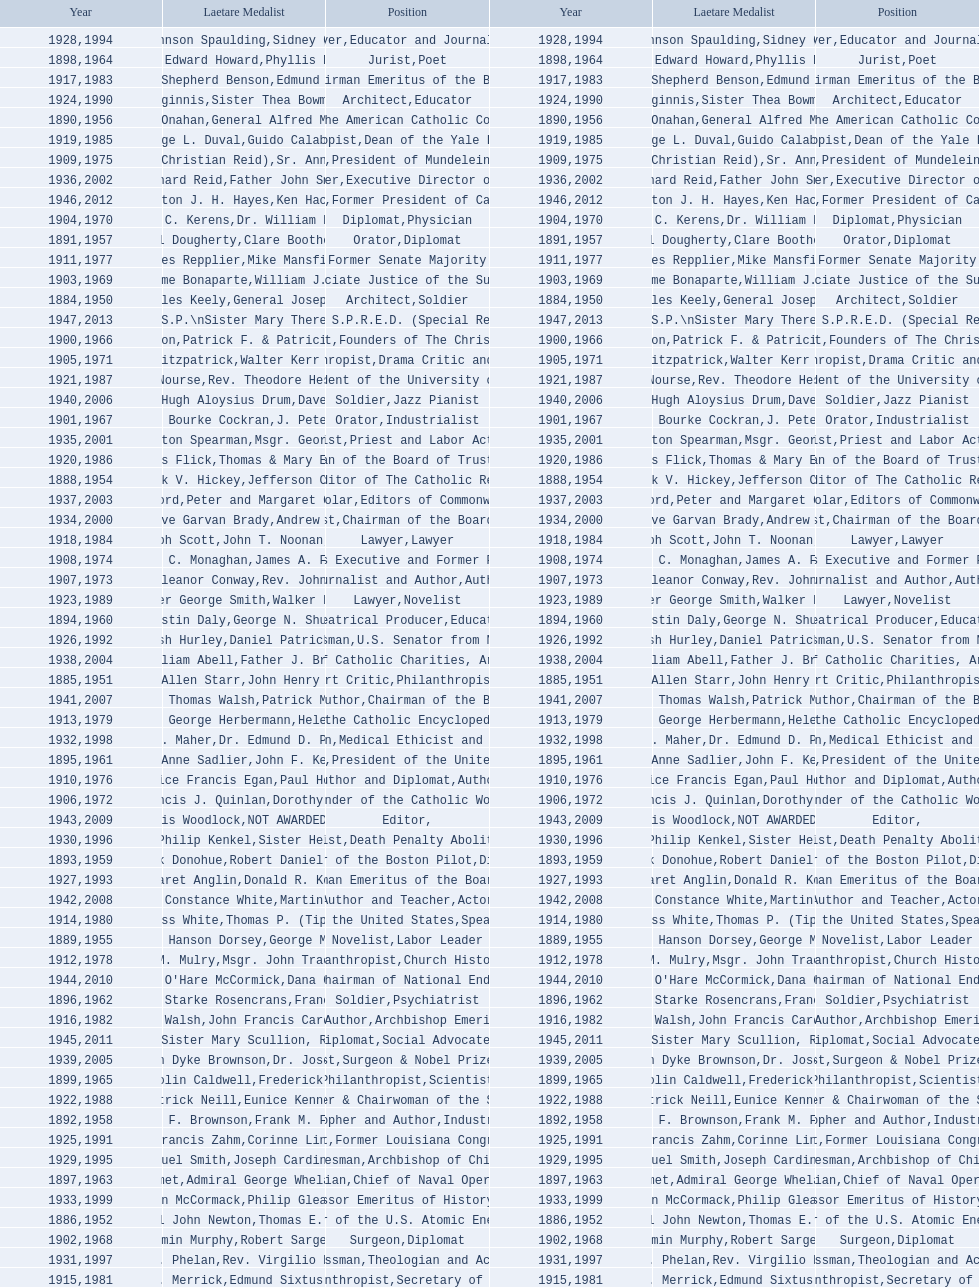What are the number of laetare medalist that held a diplomat position? 8. 